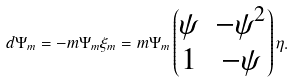Convert formula to latex. <formula><loc_0><loc_0><loc_500><loc_500>d \Psi _ { m } = - m \Psi _ { m } \xi _ { m } = m \Psi _ { m } \begin{pmatrix} \psi & - \psi ^ { 2 } \\ 1 & - \psi \end{pmatrix} \eta .</formula> 